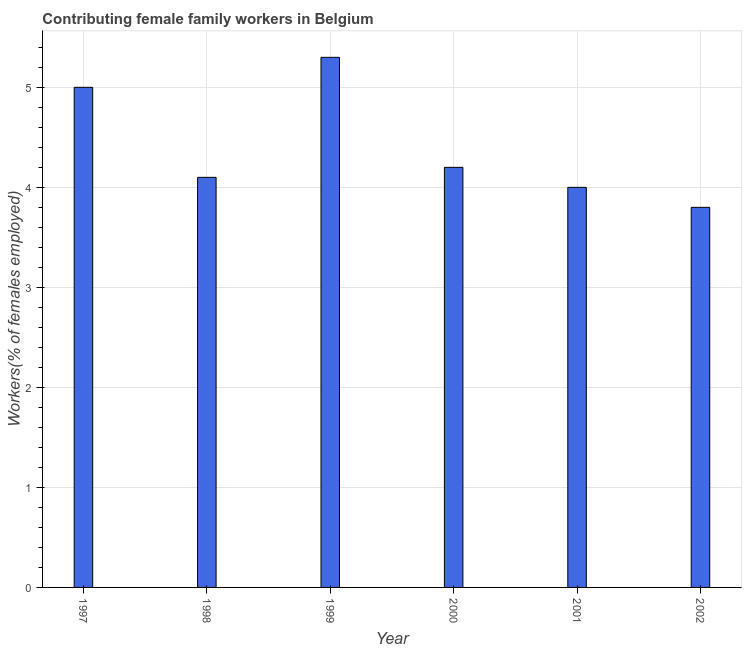Does the graph contain grids?
Provide a succinct answer. Yes. What is the title of the graph?
Offer a very short reply. Contributing female family workers in Belgium. What is the label or title of the Y-axis?
Keep it short and to the point. Workers(% of females employed). What is the contributing female family workers in 1999?
Your answer should be very brief. 5.3. Across all years, what is the maximum contributing female family workers?
Provide a succinct answer. 5.3. Across all years, what is the minimum contributing female family workers?
Offer a very short reply. 3.8. What is the sum of the contributing female family workers?
Provide a succinct answer. 26.4. What is the difference between the contributing female family workers in 1998 and 2001?
Offer a terse response. 0.1. What is the average contributing female family workers per year?
Your answer should be very brief. 4.4. What is the median contributing female family workers?
Offer a very short reply. 4.15. Do a majority of the years between 2002 and 2001 (inclusive) have contributing female family workers greater than 0.8 %?
Make the answer very short. No. What is the ratio of the contributing female family workers in 1997 to that in 2001?
Give a very brief answer. 1.25. Is the sum of the contributing female family workers in 1998 and 1999 greater than the maximum contributing female family workers across all years?
Your answer should be compact. Yes. What is the difference between the highest and the lowest contributing female family workers?
Make the answer very short. 1.5. In how many years, is the contributing female family workers greater than the average contributing female family workers taken over all years?
Your answer should be compact. 2. How many bars are there?
Your answer should be very brief. 6. Are the values on the major ticks of Y-axis written in scientific E-notation?
Give a very brief answer. No. What is the Workers(% of females employed) of 1997?
Your response must be concise. 5. What is the Workers(% of females employed) of 1998?
Make the answer very short. 4.1. What is the Workers(% of females employed) in 1999?
Offer a terse response. 5.3. What is the Workers(% of females employed) of 2000?
Provide a succinct answer. 4.2. What is the Workers(% of females employed) in 2002?
Offer a terse response. 3.8. What is the difference between the Workers(% of females employed) in 1997 and 1999?
Provide a succinct answer. -0.3. What is the difference between the Workers(% of females employed) in 1997 and 2000?
Give a very brief answer. 0.8. What is the difference between the Workers(% of females employed) in 1998 and 2002?
Provide a short and direct response. 0.3. What is the difference between the Workers(% of females employed) in 1999 and 2000?
Your response must be concise. 1.1. What is the difference between the Workers(% of females employed) in 1999 and 2002?
Your answer should be compact. 1.5. What is the ratio of the Workers(% of females employed) in 1997 to that in 1998?
Provide a short and direct response. 1.22. What is the ratio of the Workers(% of females employed) in 1997 to that in 1999?
Ensure brevity in your answer.  0.94. What is the ratio of the Workers(% of females employed) in 1997 to that in 2000?
Provide a succinct answer. 1.19. What is the ratio of the Workers(% of females employed) in 1997 to that in 2001?
Keep it short and to the point. 1.25. What is the ratio of the Workers(% of females employed) in 1997 to that in 2002?
Your response must be concise. 1.32. What is the ratio of the Workers(% of females employed) in 1998 to that in 1999?
Ensure brevity in your answer.  0.77. What is the ratio of the Workers(% of females employed) in 1998 to that in 2000?
Keep it short and to the point. 0.98. What is the ratio of the Workers(% of females employed) in 1998 to that in 2002?
Keep it short and to the point. 1.08. What is the ratio of the Workers(% of females employed) in 1999 to that in 2000?
Your answer should be very brief. 1.26. What is the ratio of the Workers(% of females employed) in 1999 to that in 2001?
Provide a succinct answer. 1.32. What is the ratio of the Workers(% of females employed) in 1999 to that in 2002?
Offer a very short reply. 1.4. What is the ratio of the Workers(% of females employed) in 2000 to that in 2002?
Offer a terse response. 1.1. What is the ratio of the Workers(% of females employed) in 2001 to that in 2002?
Give a very brief answer. 1.05. 